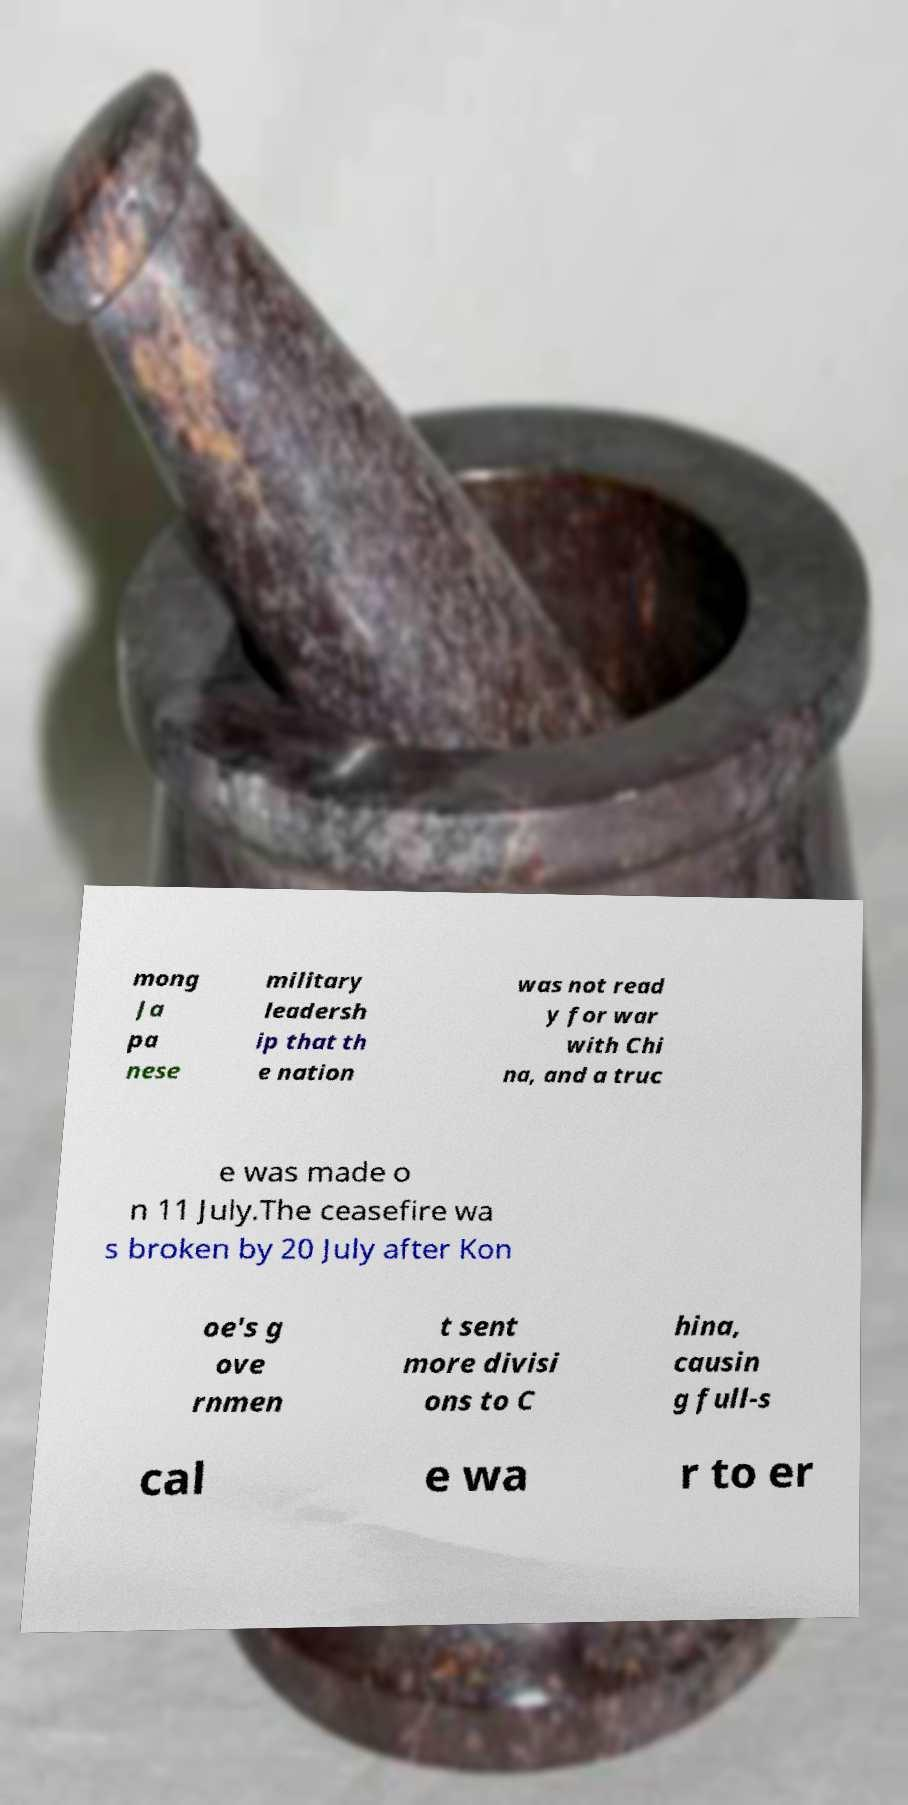What messages or text are displayed in this image? I need them in a readable, typed format. mong Ja pa nese military leadersh ip that th e nation was not read y for war with Chi na, and a truc e was made o n 11 July.The ceasefire wa s broken by 20 July after Kon oe's g ove rnmen t sent more divisi ons to C hina, causin g full-s cal e wa r to er 